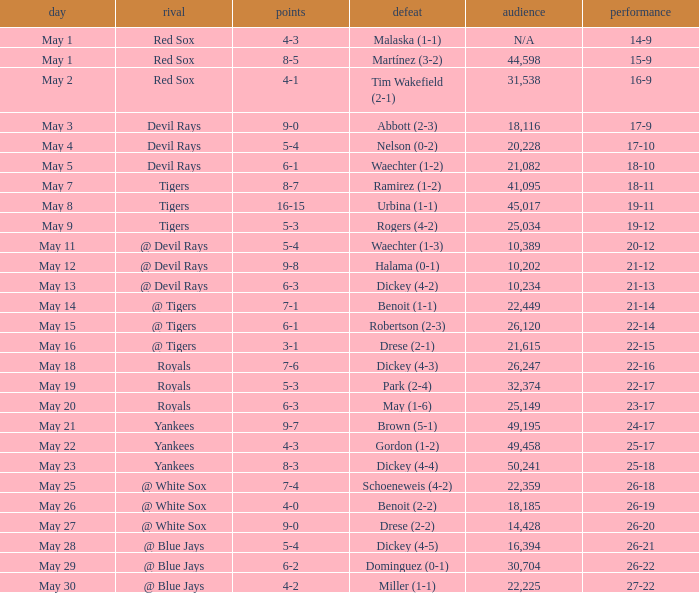Would you be able to parse every entry in this table? {'header': ['day', 'rival', 'points', 'defeat', 'audience', 'performance'], 'rows': [['May 1', 'Red Sox', '4-3', 'Malaska (1-1)', 'N/A', '14-9'], ['May 1', 'Red Sox', '8-5', 'Martínez (3-2)', '44,598', '15-9'], ['May 2', 'Red Sox', '4-1', 'Tim Wakefield (2-1)', '31,538', '16-9'], ['May 3', 'Devil Rays', '9-0', 'Abbott (2-3)', '18,116', '17-9'], ['May 4', 'Devil Rays', '5-4', 'Nelson (0-2)', '20,228', '17-10'], ['May 5', 'Devil Rays', '6-1', 'Waechter (1-2)', '21,082', '18-10'], ['May 7', 'Tigers', '8-7', 'Ramirez (1-2)', '41,095', '18-11'], ['May 8', 'Tigers', '16-15', 'Urbina (1-1)', '45,017', '19-11'], ['May 9', 'Tigers', '5-3', 'Rogers (4-2)', '25,034', '19-12'], ['May 11', '@ Devil Rays', '5-4', 'Waechter (1-3)', '10,389', '20-12'], ['May 12', '@ Devil Rays', '9-8', 'Halama (0-1)', '10,202', '21-12'], ['May 13', '@ Devil Rays', '6-3', 'Dickey (4-2)', '10,234', '21-13'], ['May 14', '@ Tigers', '7-1', 'Benoit (1-1)', '22,449', '21-14'], ['May 15', '@ Tigers', '6-1', 'Robertson (2-3)', '26,120', '22-14'], ['May 16', '@ Tigers', '3-1', 'Drese (2-1)', '21,615', '22-15'], ['May 18', 'Royals', '7-6', 'Dickey (4-3)', '26,247', '22-16'], ['May 19', 'Royals', '5-3', 'Park (2-4)', '32,374', '22-17'], ['May 20', 'Royals', '6-3', 'May (1-6)', '25,149', '23-17'], ['May 21', 'Yankees', '9-7', 'Brown (5-1)', '49,195', '24-17'], ['May 22', 'Yankees', '4-3', 'Gordon (1-2)', '49,458', '25-17'], ['May 23', 'Yankees', '8-3', 'Dickey (4-4)', '50,241', '25-18'], ['May 25', '@ White Sox', '7-4', 'Schoeneweis (4-2)', '22,359', '26-18'], ['May 26', '@ White Sox', '4-0', 'Benoit (2-2)', '18,185', '26-19'], ['May 27', '@ White Sox', '9-0', 'Drese (2-2)', '14,428', '26-20'], ['May 28', '@ Blue Jays', '5-4', 'Dickey (4-5)', '16,394', '26-21'], ['May 29', '@ Blue Jays', '6-2', 'Dominguez (0-1)', '30,704', '26-22'], ['May 30', '@ Blue Jays', '4-2', 'Miller (1-1)', '22,225', '27-22']]} What was the outcome of the match featuring a defeat of drese (2-2)? 9-0. 